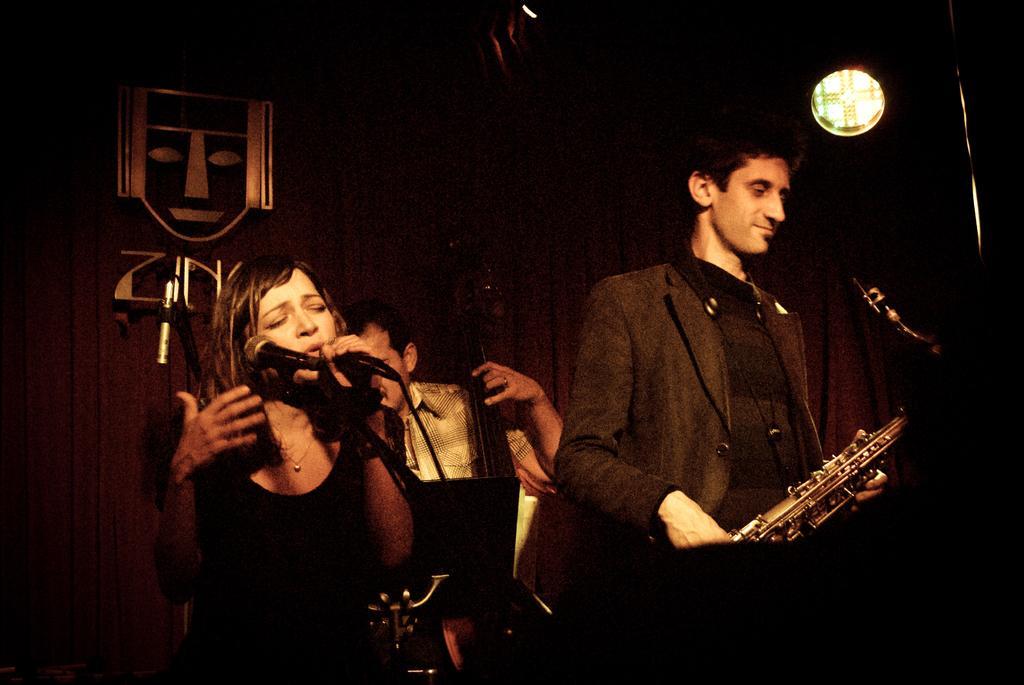Please provide a concise description of this image. In this image we can see persons standing on the floor and holding musical instruments in their hands. In the background we can see curtain. 